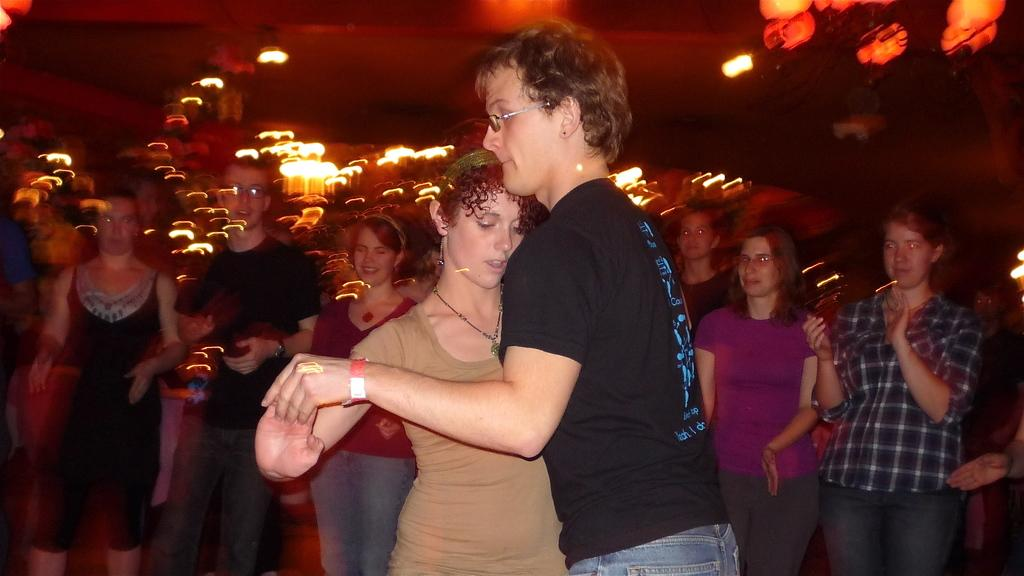Who or what can be seen in the image? There are people in the image. What is above the people in the image? There is a ceiling with lights in the image. What type of poison is being used by the people in the image? There is no indication of poison or any dangerous substances in the image. The people appear to be in a normal setting, and there is no mention of a kite or calendar in the image. 